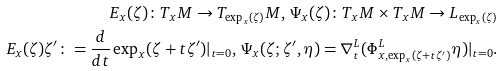Convert formula to latex. <formula><loc_0><loc_0><loc_500><loc_500>E _ { x } ( \zeta ) \colon T _ { x } M \to T _ { \exp _ { x } ( \zeta ) } M , \, \Psi _ { x } ( \zeta ) \colon T _ { x } M \times T _ { x } M \to L _ { \exp _ { x } ( \zeta ) } \\ E _ { x } ( \zeta ) \zeta ^ { \prime } \colon = \frac { d } { d t } \exp _ { x } ( \zeta + t \zeta ^ { \prime } ) | _ { t = 0 } , \, \Psi _ { x } ( \zeta ; \zeta ^ { \prime } , \eta ) = \nabla ^ { L } _ { t } ( \Phi ^ { L } _ { x , \exp _ { x } ( \zeta + t \zeta ^ { \prime } ) } \eta ) | _ { t = 0 } .</formula> 